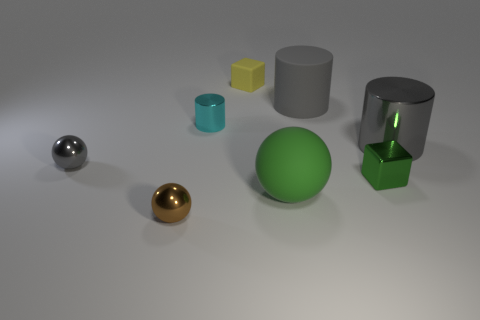Is the tiny yellow object the same shape as the small green metal object?
Offer a terse response. Yes. What is the color of the big rubber cylinder?
Provide a succinct answer. Gray. What number of other objects are the same material as the green sphere?
Provide a short and direct response. 2. How many cyan objects are either shiny things or blocks?
Keep it short and to the point. 1. Do the cyan metallic object that is to the left of the big metallic cylinder and the tiny metallic thing in front of the big green matte ball have the same shape?
Provide a short and direct response. No. There is a large ball; does it have the same color as the tiny cube right of the matte sphere?
Provide a succinct answer. Yes. There is a small block right of the tiny yellow rubber object; does it have the same color as the large matte sphere?
Offer a terse response. Yes. How many objects are either tiny metal things or tiny metal spheres in front of the green matte ball?
Ensure brevity in your answer.  4. What is the material of the small thing that is on the right side of the small shiny cylinder and behind the small gray metal thing?
Keep it short and to the point. Rubber. There is a large green object right of the brown sphere; what is its material?
Your answer should be very brief. Rubber. 